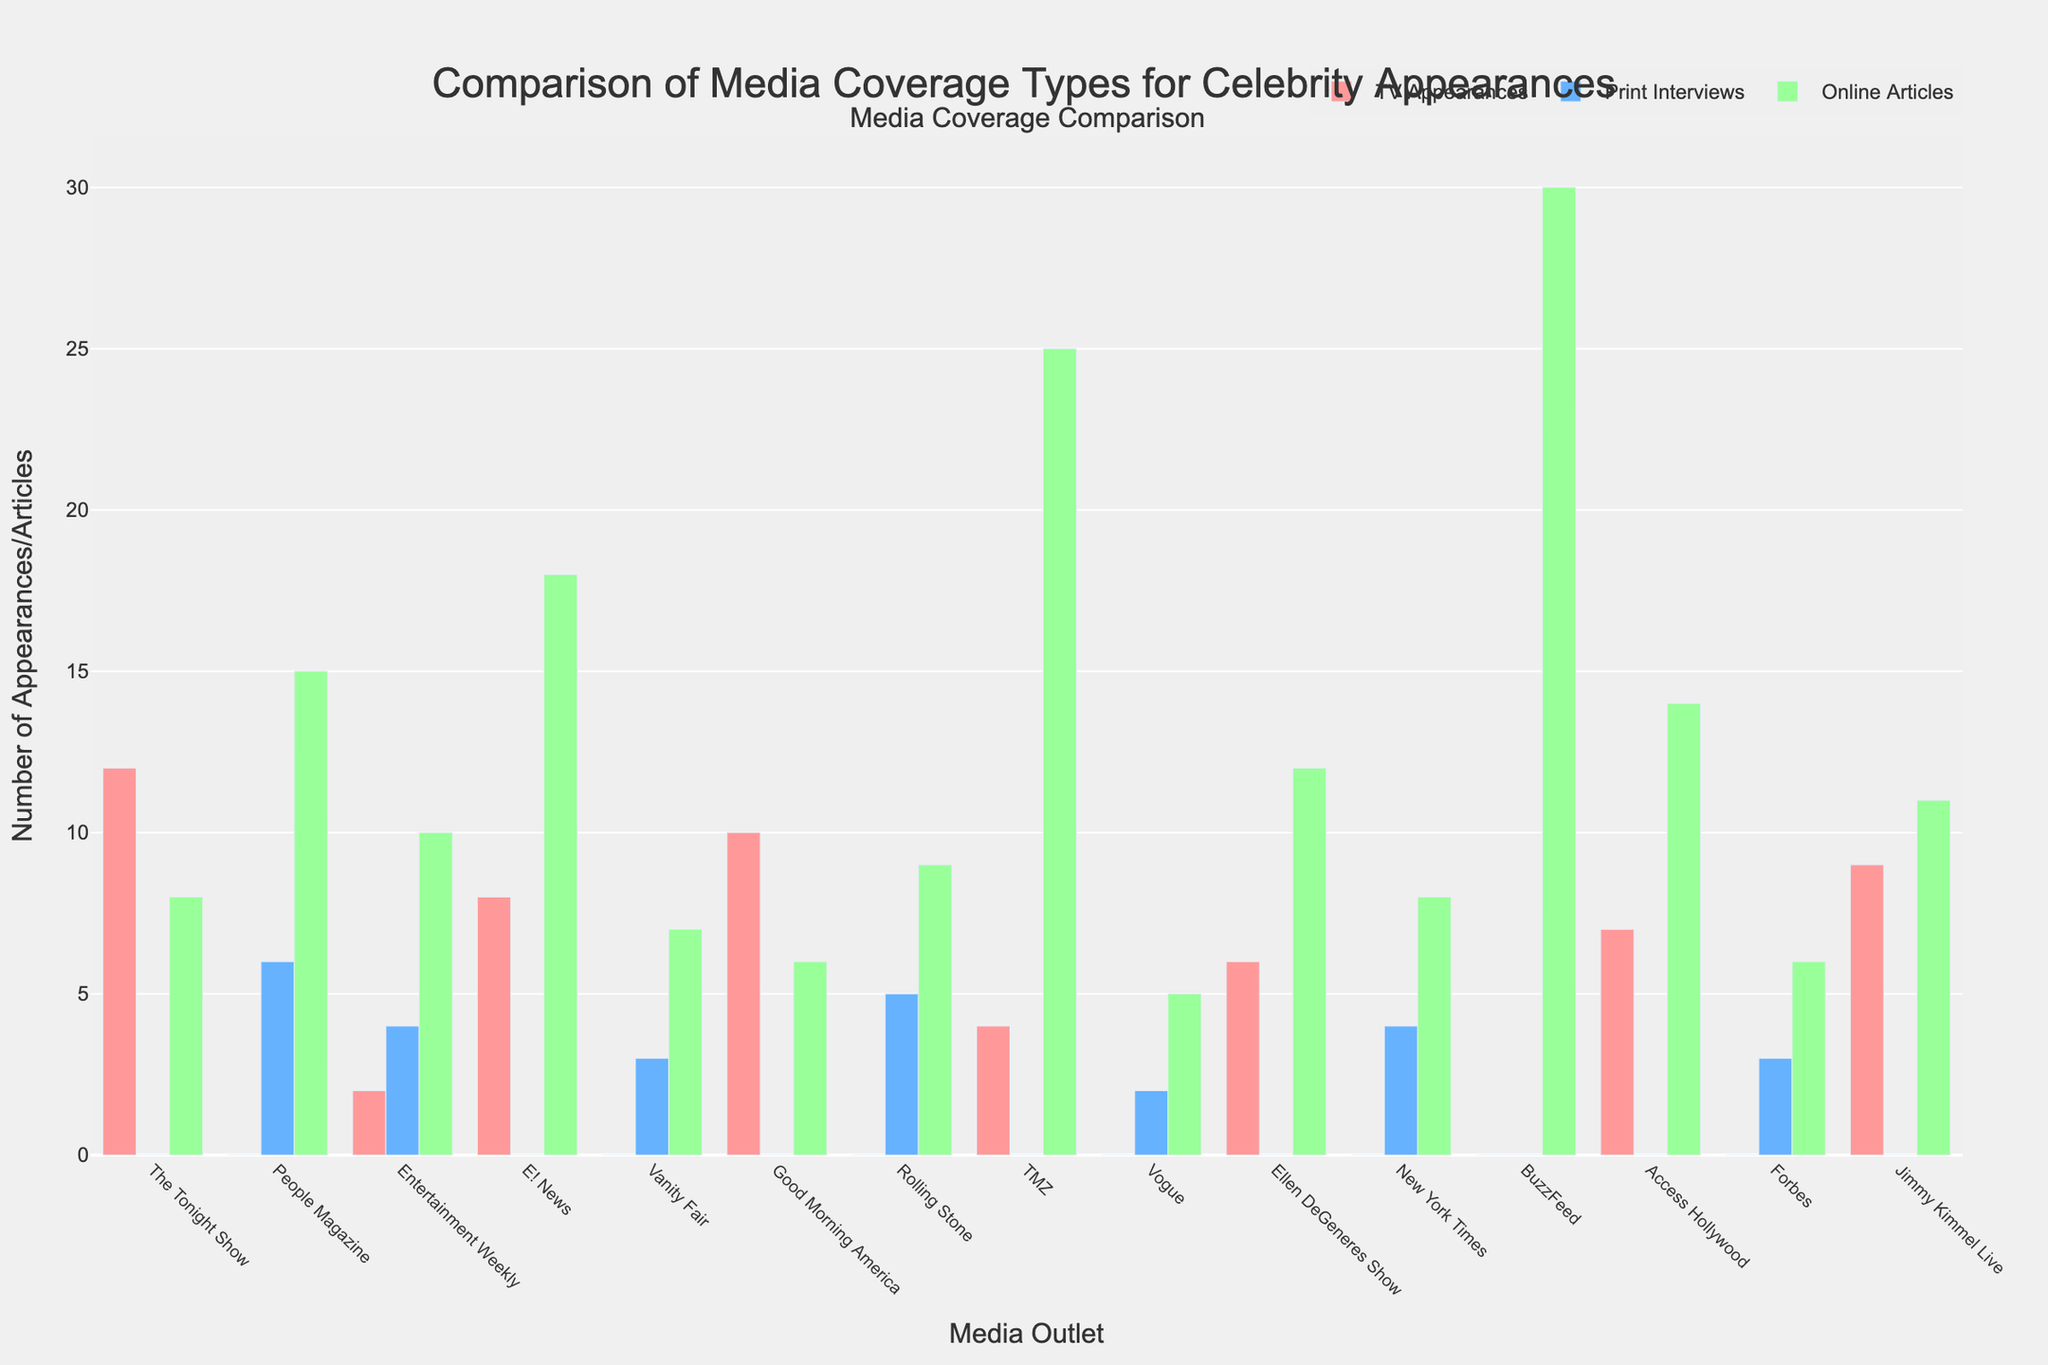Which media outlet has the highest number of TV Appearances? The bar labeled "Good Morning America" is the tallest among the TV Appearances, indicating the highest number.
Answer: Good Morning America How many media outlets have print interviews? Calculate the number of media outlets with non-zero bars in the Print Interviews category.
Answer: 8 Which media outlet has the most online articles, and how many? The bar labeled "BuzzFeed" is the tallest among the online articles, indicating the highest number. By reading the height, the number is 30.
Answer: BuzzFeed, 30 What is the total number of TV appearances across all media outlets? Sum the heights of all bars in the TV Appearances category: 12+0+2+8+0+10+0+4+0+6+0+0+7+0+9 = 58
Answer: 58 Does any media outlet have coverage in all three categories (TV Appearances, Print Interviews, and Online Articles)? Check if any single media outlet column has non-zero bars in all three categories. No media outlet does.
Answer: No Which type of media coverage has the highest total count across all outlets? Sum the counts for TV Appearances, Print Interviews, and Online Articles: TV Appearances: 58; Print Interviews: 27; Online Articles: 184. Online Articles have the highest count.
Answer: Online Articles What is the difference in the number of online articles between TMZ and People Magazine? Subtract the number of online articles for People Magazine from those for TMZ: 25 - 15 = 10
Answer: 10 Which media outlets have no TV appearances but have online articles? Identify bars that have zero in TV Appearances but greater than zero in Online Articles: People Magazine, Vanity Fair, Rolling Stone, Vogue, New York Times, BuzzFeed, Forbes.
Answer: People Magazine, Vanity Fair, Rolling Stone, Vogue, New York Times, BuzzFeed, Forbes How many more TV Appearances does Jimmy Kimmel Live have compared to Entertainment Weekly? Subtract the number of TV Appearances for Entertainment Weekly from those for Jimmy Kimmel Live: 9 - 2 = 7
Answer: 7 What is the average number of print interviews across all media outlets? Sum the number of print interviews and divide by the number of media outlets: (0+6+4+0+3+0+5+0+2+0+4+0+0+3+0) / 15 = 27 / 15 = 1.8
Answer: 1.8 